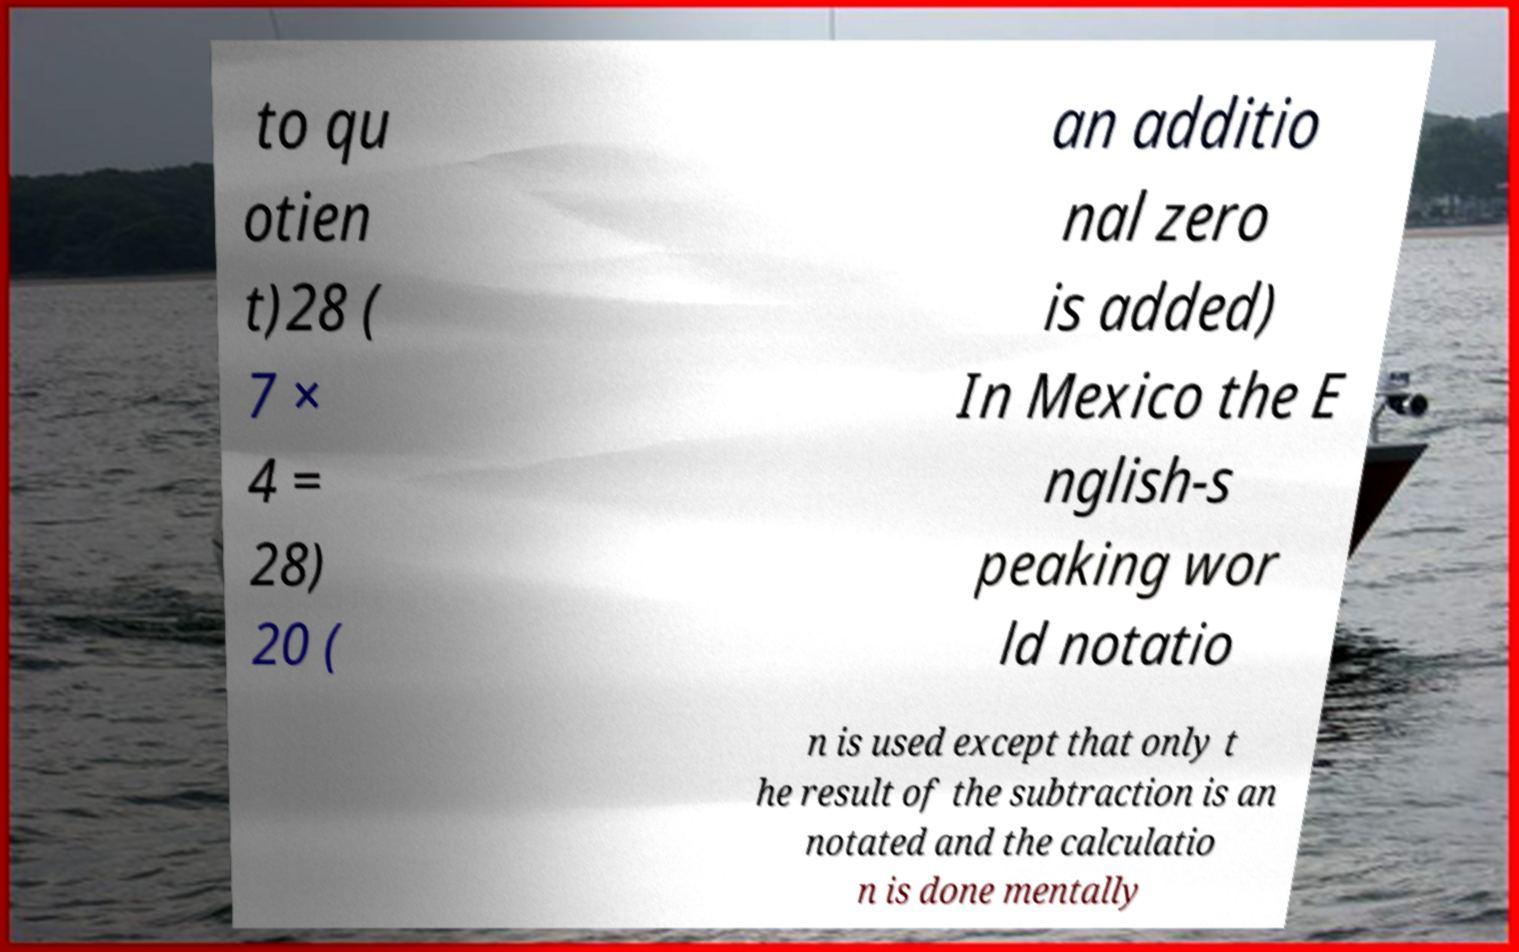What messages or text are displayed in this image? I need them in a readable, typed format. to qu otien t)28 ( 7 × 4 = 28) 20 ( an additio nal zero is added) In Mexico the E nglish-s peaking wor ld notatio n is used except that only t he result of the subtraction is an notated and the calculatio n is done mentally 